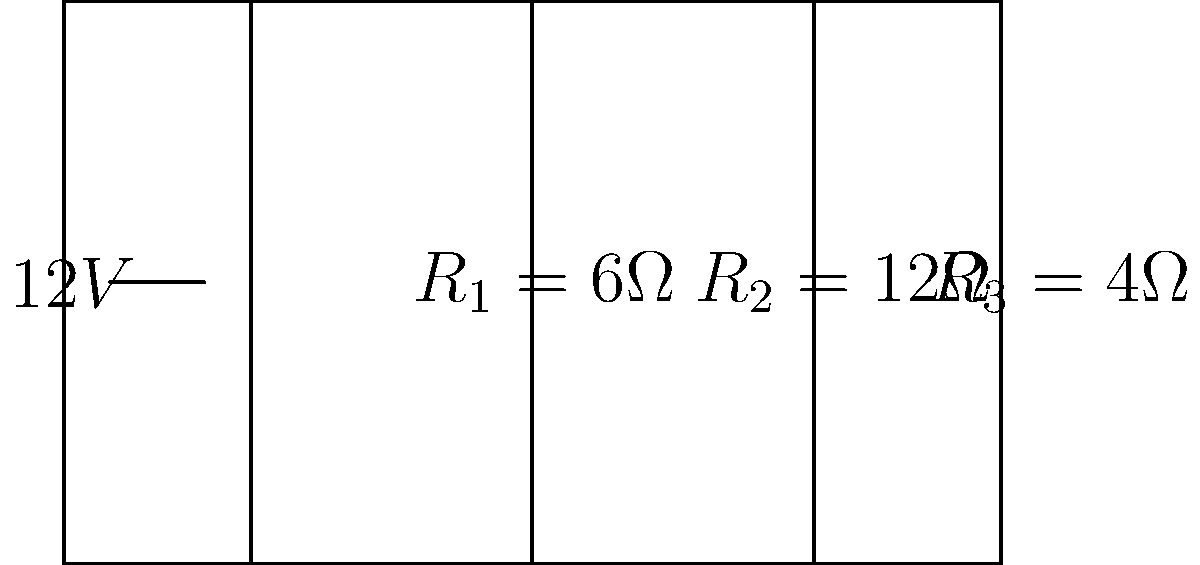In the parallel circuit shown above, what is the voltage drop across resistor $R_2$? To determine the voltage drop across $R_2$, we can follow these steps:

1) In a parallel circuit, the voltage is the same across all components. This means the voltage drop across each resistor is equal to the source voltage.

2) The source voltage in this circuit is 12V.

3) Therefore, the voltage drop across $R_2$ is the same as the source voltage, which is 12V.

Note: In a parallel circuit, the current divides among the branches, but the voltage remains constant across all components. This is different from a series circuit, where the voltage is divided among components.
Answer: 12V 